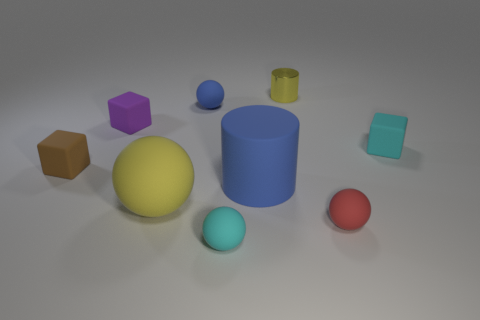What material is the yellow object that is behind the matte cube behind the matte cube on the right side of the small cyan sphere?
Your response must be concise. Metal. Does the blue rubber thing that is in front of the small blue thing have the same shape as the tiny cyan object that is behind the red rubber ball?
Your answer should be very brief. No. Is there a blue rubber cylinder of the same size as the blue matte ball?
Provide a short and direct response. No. What number of blue things are either tiny metal cylinders or big things?
Your response must be concise. 1. What number of blocks have the same color as the large cylinder?
Make the answer very short. 0. Is there any other thing that is the same shape as the brown thing?
Your answer should be compact. Yes. How many cylinders are either tiny rubber things or blue objects?
Offer a terse response. 1. What is the color of the block that is on the right side of the big yellow matte thing?
Give a very brief answer. Cyan. There is another metal thing that is the same size as the purple thing; what is its shape?
Make the answer very short. Cylinder. There is a yellow metallic object; what number of small cyan objects are to the right of it?
Your answer should be very brief. 1. 